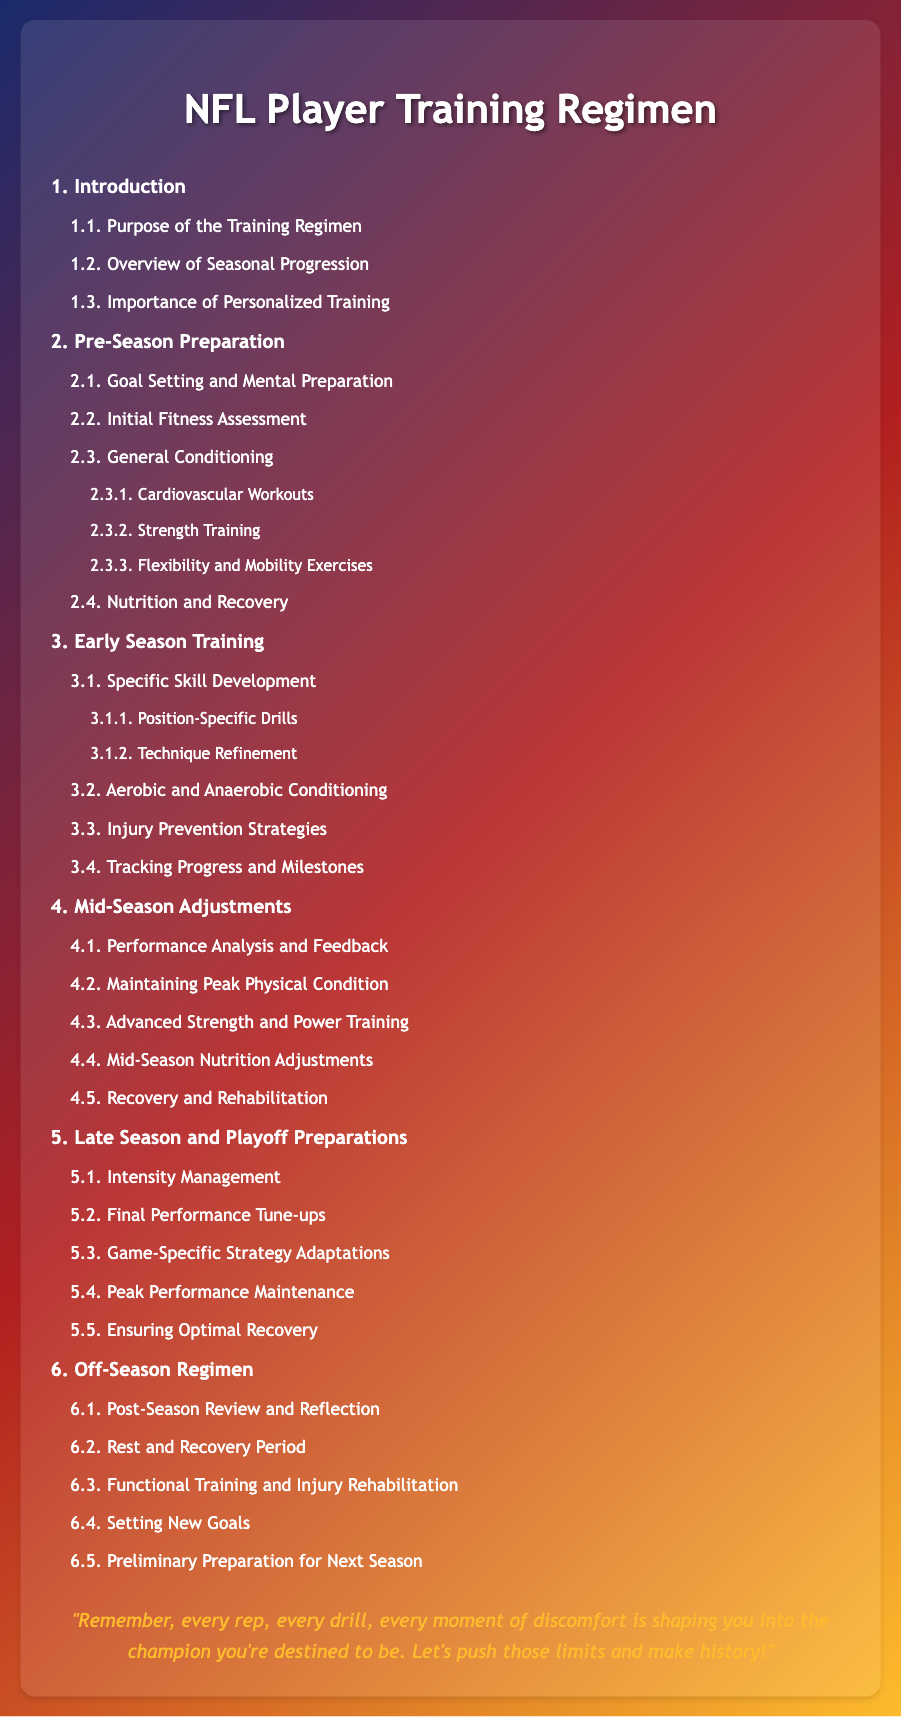What is the title of the document? The title of the document is indicated prominently at the top of the page.
Answer: NFL Player Training Regimen What section covers Pre-Season Preparation? The section number associated with Pre-Season Preparation is used to organize the content.
Answer: 2 What is the purpose of the training regimen? This specific information is found in the subsection detailing the objectives of the regimen.
Answer: Purpose of the Training Regimen How many levels are there in the table of contents? The levels are indicated by their respective hierarchy in the document outline.
Answer: Three What does section 4 focus on? Section 4 is specifically about adjustments made during the season.
Answer: Mid-Season Adjustments What are the two types of conditioning mentioned in section 3.2? The section addresses different conditioning methods aimed at enhancing performance.
Answer: Aerobic and Anaerobic What document type does this table of contents represent? The overall organization and structure suggest the type of document it is.
Answer: Table of contents What is the final goal mentioned in section 6.4? The section outlines future objectives following the off-season preparation.
Answer: Setting New Goals What is contained in the motivational quote at the end? The quote serves as encouragement and inspiration related to training and performance.
Answer: Every rep, every drill, every moment of discomfort is shaping you into the champion you're destined to be 